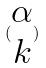<formula> <loc_0><loc_0><loc_500><loc_500>( \begin{matrix} \alpha \\ k \end{matrix} )</formula> 